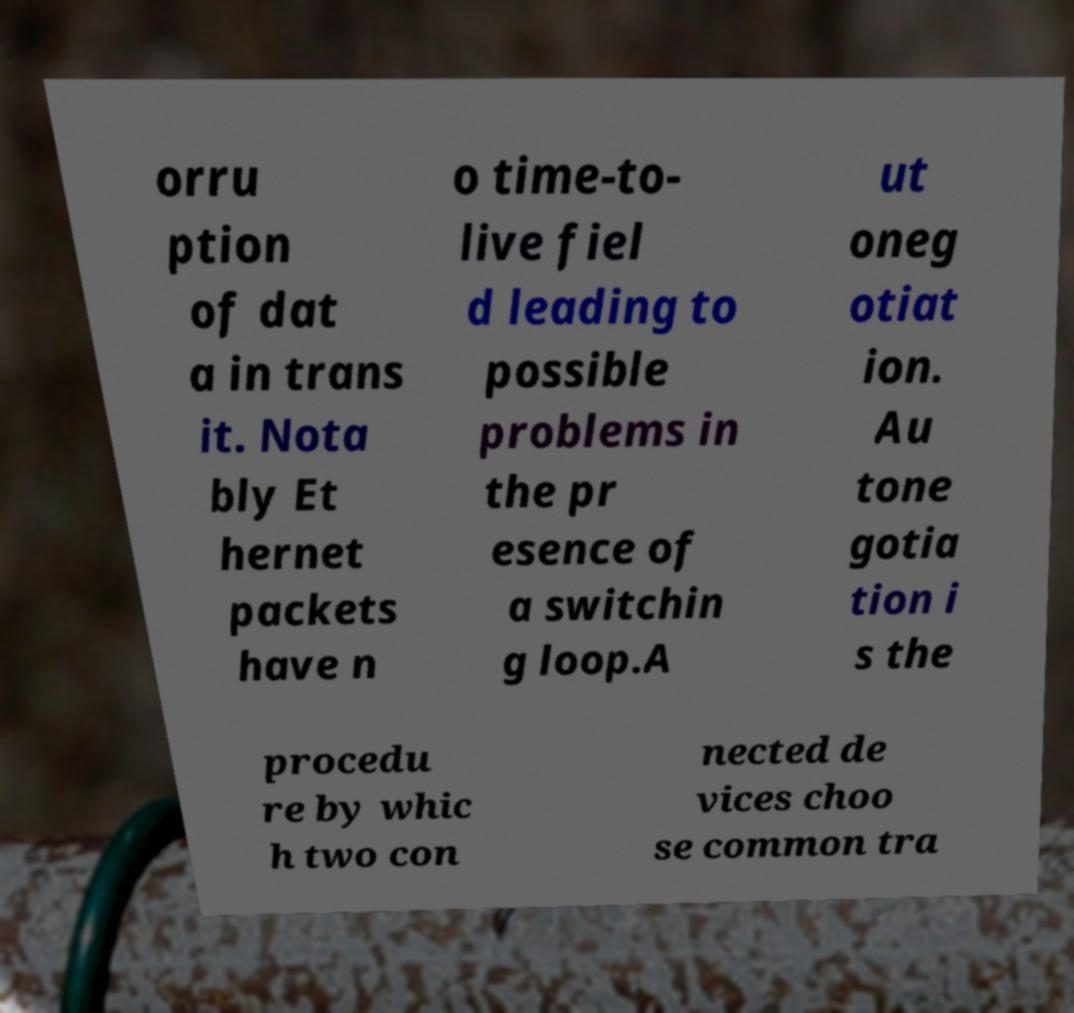Can you read and provide the text displayed in the image?This photo seems to have some interesting text. Can you extract and type it out for me? orru ption of dat a in trans it. Nota bly Et hernet packets have n o time-to- live fiel d leading to possible problems in the pr esence of a switchin g loop.A ut oneg otiat ion. Au tone gotia tion i s the procedu re by whic h two con nected de vices choo se common tra 